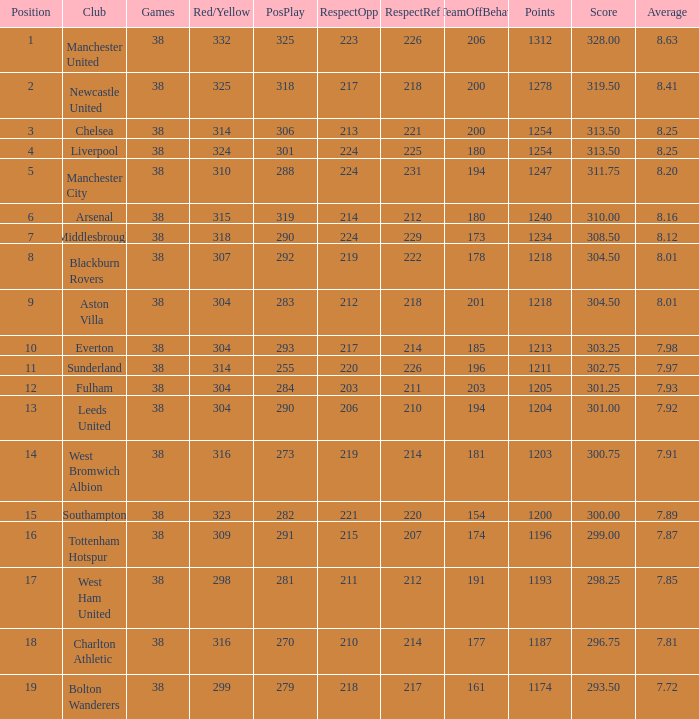Who holds the position of pos for west ham united? 17.0. 